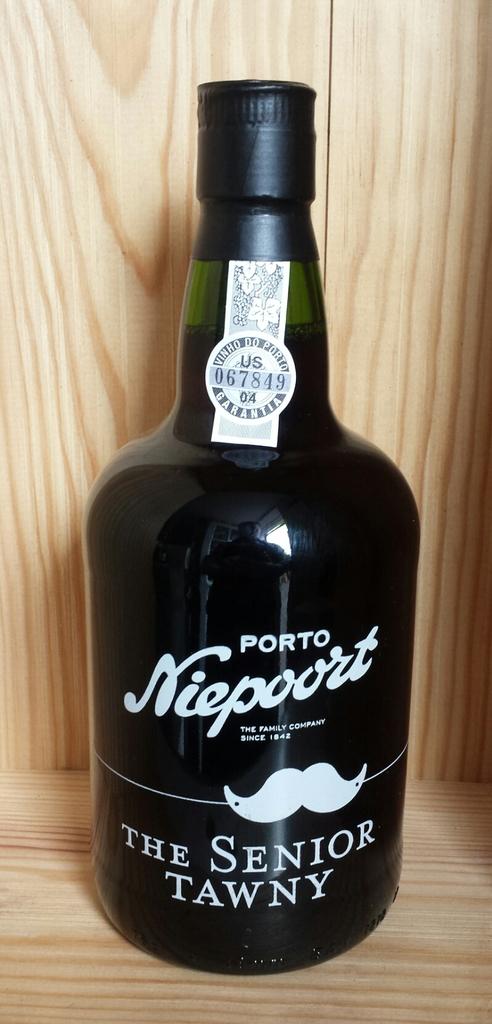What is the liquor called that porto nieport makes?
Your response must be concise. The senior tawny. 